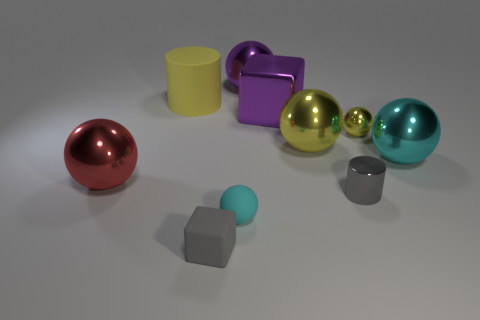What is the shape of the yellow object left of the ball that is behind the cylinder behind the red object?
Make the answer very short. Cylinder. Are there more cylinders in front of the small gray metallic thing than tiny cyan balls?
Your response must be concise. No. There is a large purple thing that is in front of the yellow rubber cylinder; does it have the same shape as the cyan metal object?
Offer a terse response. No. What material is the cylinder behind the small gray shiny thing?
Give a very brief answer. Rubber. How many tiny cyan rubber things have the same shape as the large matte object?
Your response must be concise. 0. There is a block behind the gray thing in front of the small gray metallic thing; what is it made of?
Your answer should be compact. Metal. The metal thing that is the same color as the small shiny ball is what shape?
Provide a short and direct response. Sphere. Is there a large gray cylinder made of the same material as the large cyan thing?
Offer a terse response. No. What is the shape of the big cyan object?
Provide a succinct answer. Sphere. How many large cyan metal objects are there?
Give a very brief answer. 1. 